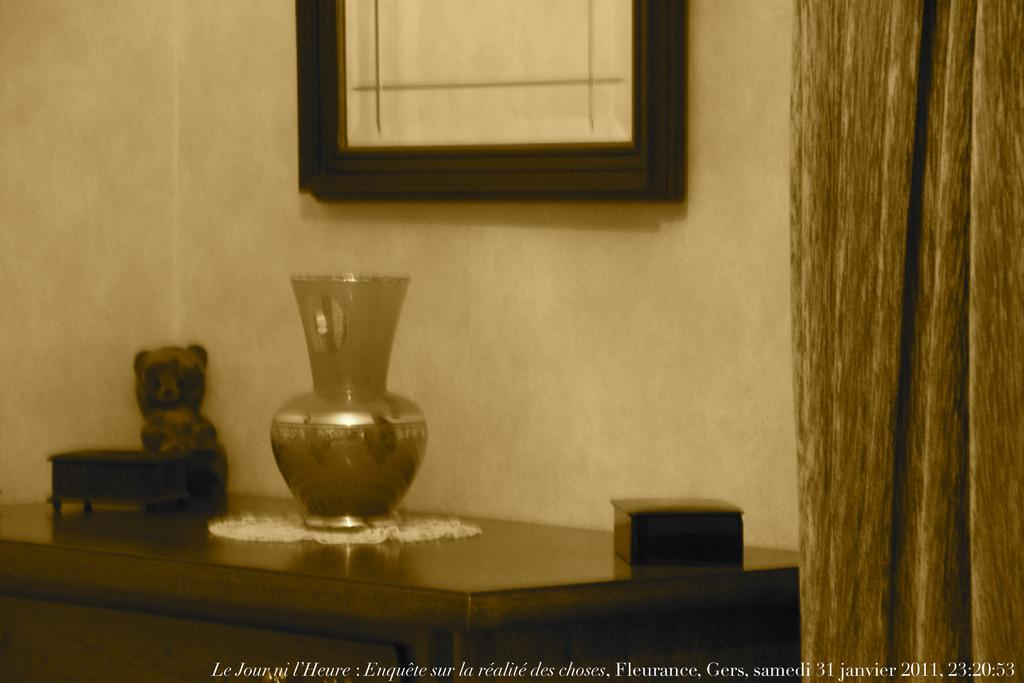What is the main piece of furniture in the image? There is a table in the image. What is placed on the table? There is a vase, a teddy bear toy, and books on the table. What is the color scheme of the image? The image is in black and white color. What type of paste is being used to stick the yarn on the table in the image? There is no paste or yarn present in the image. How does the friction between the objects on the table affect the stability of the table in the image? The provided facts do not mention any friction between objects on the table, so it is not possible to determine its effect on the table's stability. 